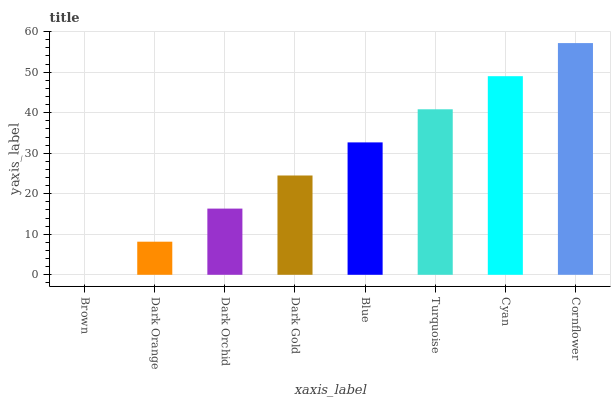Is Brown the minimum?
Answer yes or no. Yes. Is Cornflower the maximum?
Answer yes or no. Yes. Is Dark Orange the minimum?
Answer yes or no. No. Is Dark Orange the maximum?
Answer yes or no. No. Is Dark Orange greater than Brown?
Answer yes or no. Yes. Is Brown less than Dark Orange?
Answer yes or no. Yes. Is Brown greater than Dark Orange?
Answer yes or no. No. Is Dark Orange less than Brown?
Answer yes or no. No. Is Blue the high median?
Answer yes or no. Yes. Is Dark Gold the low median?
Answer yes or no. Yes. Is Dark Orange the high median?
Answer yes or no. No. Is Dark Orange the low median?
Answer yes or no. No. 